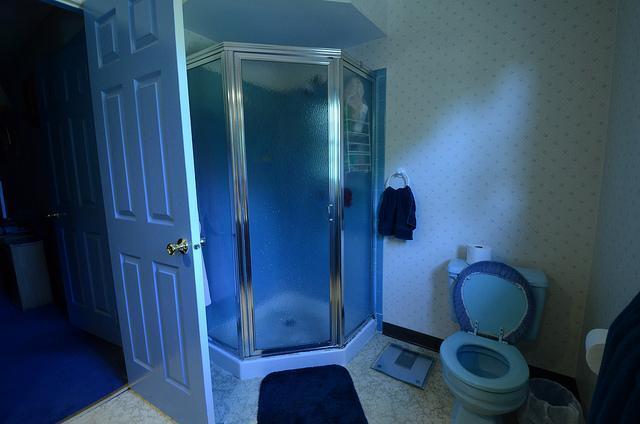How many green spray bottles are there?
Give a very brief answer. 0. 